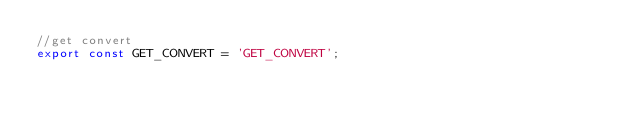Convert code to text. <code><loc_0><loc_0><loc_500><loc_500><_JavaScript_>//get convert
export const GET_CONVERT = 'GET_CONVERT';
</code> 